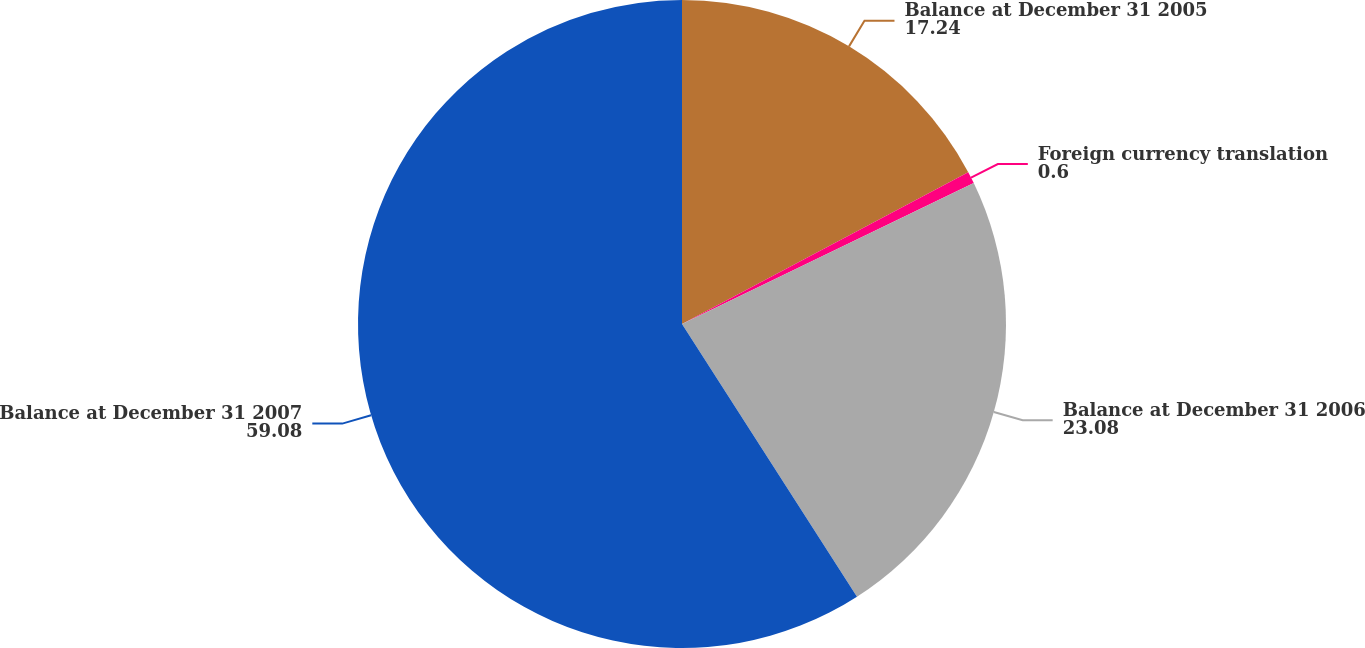<chart> <loc_0><loc_0><loc_500><loc_500><pie_chart><fcel>Balance at December 31 2005<fcel>Foreign currency translation<fcel>Balance at December 31 2006<fcel>Balance at December 31 2007<nl><fcel>17.24%<fcel>0.6%<fcel>23.08%<fcel>59.08%<nl></chart> 